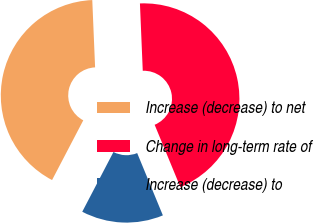Convert chart. <chart><loc_0><loc_0><loc_500><loc_500><pie_chart><fcel>Increase (decrease) to net<fcel>Change in long-term rate of<fcel>Increase (decrease) to<nl><fcel>41.67%<fcel>44.44%<fcel>13.89%<nl></chart> 